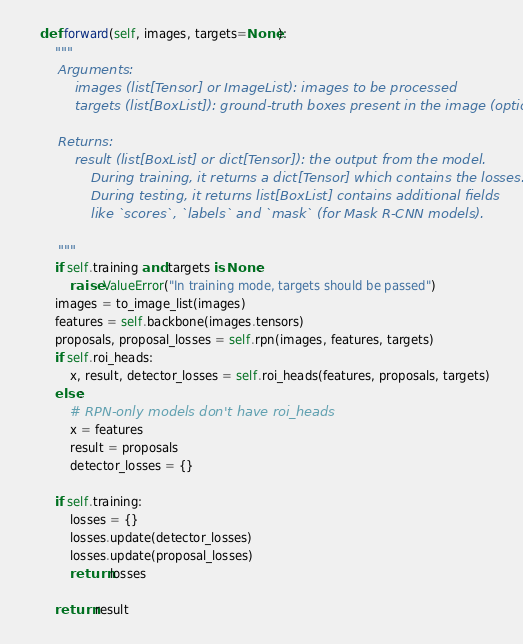Convert code to text. <code><loc_0><loc_0><loc_500><loc_500><_Python_>    def forward(self, images, targets=None):
        """
        Arguments:
            images (list[Tensor] or ImageList): images to be processed
            targets (list[BoxList]): ground-truth boxes present in the image (optional)

        Returns:
            result (list[BoxList] or dict[Tensor]): the output from the model.
                During training, it returns a dict[Tensor] which contains the losses.
                During testing, it returns list[BoxList] contains additional fields
                like `scores`, `labels` and `mask` (for Mask R-CNN models).

        """
        if self.training and targets is None:
            raise ValueError("In training mode, targets should be passed")
        images = to_image_list(images)
        features = self.backbone(images.tensors)
        proposals, proposal_losses = self.rpn(images, features, targets)
        if self.roi_heads:
            x, result, detector_losses = self.roi_heads(features, proposals, targets)
        else:
            # RPN-only models don't have roi_heads
            x = features
            result = proposals
            detector_losses = {}

        if self.training:
            losses = {}
            losses.update(detector_losses)
            losses.update(proposal_losses)
            return losses

        return result
</code> 